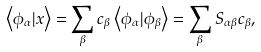Convert formula to latex. <formula><loc_0><loc_0><loc_500><loc_500>\left < \phi _ { \alpha } | x \right > = \sum _ { \beta } c _ { \beta } \left < \phi _ { \alpha } | \phi _ { \beta } \right > = \sum _ { \beta } S _ { \alpha \beta } c _ { \beta } ,</formula> 